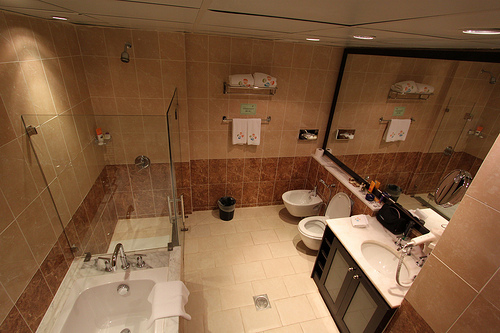How is the lighting arranged in this bathroom? The bathroom lighting seems to be chiefly provided by a series of recessed ceiling lights, which give a clean and modern look while ensuring ample illumination throughout the space. 